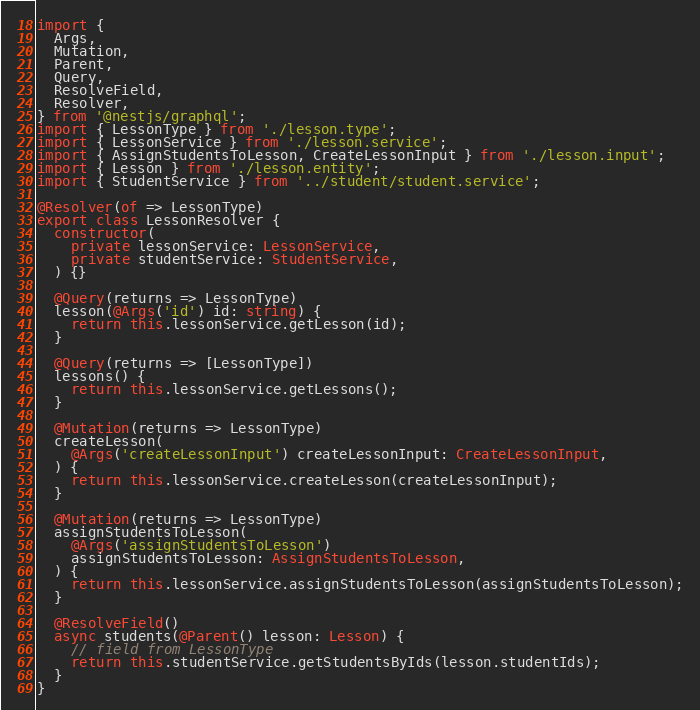Convert code to text. <code><loc_0><loc_0><loc_500><loc_500><_TypeScript_>import {
  Args,
  Mutation,
  Parent,
  Query,
  ResolveField,
  Resolver,
} from '@nestjs/graphql';
import { LessonType } from './lesson.type';
import { LessonService } from './lesson.service';
import { AssignStudentsToLesson, CreateLessonInput } from './lesson.input';
import { Lesson } from './lesson.entity';
import { StudentService } from '../student/student.service';

@Resolver(of => LessonType)
export class LessonResolver {
  constructor(
    private lessonService: LessonService,
    private studentService: StudentService,
  ) {}

  @Query(returns => LessonType)
  lesson(@Args('id') id: string) {
    return this.lessonService.getLesson(id);
  }

  @Query(returns => [LessonType])
  lessons() {
    return this.lessonService.getLessons();
  }

  @Mutation(returns => LessonType)
  createLesson(
    @Args('createLessonInput') createLessonInput: CreateLessonInput,
  ) {
    return this.lessonService.createLesson(createLessonInput);
  }

  @Mutation(returns => LessonType)
  assignStudentsToLesson(
    @Args('assignStudentsToLesson')
    assignStudentsToLesson: AssignStudentsToLesson,
  ) {
    return this.lessonService.assignStudentsToLesson(assignStudentsToLesson);
  }

  @ResolveField()
  async students(@Parent() lesson: Lesson) {
    // field from LessonType
    return this.studentService.getStudentsByIds(lesson.studentIds);
  }
}
</code> 